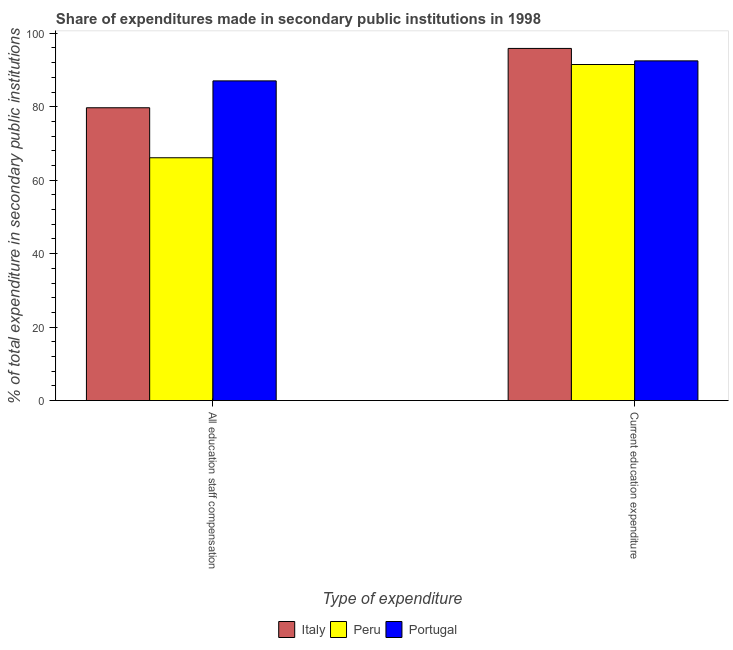How many groups of bars are there?
Offer a terse response. 2. Are the number of bars per tick equal to the number of legend labels?
Give a very brief answer. Yes. How many bars are there on the 1st tick from the right?
Ensure brevity in your answer.  3. What is the label of the 2nd group of bars from the left?
Keep it short and to the point. Current education expenditure. What is the expenditure in education in Portugal?
Ensure brevity in your answer.  92.49. Across all countries, what is the maximum expenditure in education?
Offer a terse response. 95.87. Across all countries, what is the minimum expenditure in education?
Give a very brief answer. 91.49. In which country was the expenditure in staff compensation maximum?
Your answer should be compact. Portugal. In which country was the expenditure in education minimum?
Provide a short and direct response. Peru. What is the total expenditure in staff compensation in the graph?
Give a very brief answer. 232.87. What is the difference between the expenditure in education in Peru and that in Italy?
Make the answer very short. -4.38. What is the difference between the expenditure in staff compensation in Portugal and the expenditure in education in Italy?
Your response must be concise. -8.83. What is the average expenditure in staff compensation per country?
Keep it short and to the point. 77.62. What is the difference between the expenditure in education and expenditure in staff compensation in Italy?
Keep it short and to the point. 16.15. In how many countries, is the expenditure in staff compensation greater than 72 %?
Offer a terse response. 2. What is the ratio of the expenditure in staff compensation in Portugal to that in Peru?
Keep it short and to the point. 1.32. What does the 2nd bar from the left in Current education expenditure represents?
Keep it short and to the point. Peru. How many countries are there in the graph?
Provide a succinct answer. 3. What is the difference between two consecutive major ticks on the Y-axis?
Ensure brevity in your answer.  20. Are the values on the major ticks of Y-axis written in scientific E-notation?
Give a very brief answer. No. Does the graph contain grids?
Make the answer very short. No. Where does the legend appear in the graph?
Offer a very short reply. Bottom center. How many legend labels are there?
Offer a terse response. 3. What is the title of the graph?
Offer a very short reply. Share of expenditures made in secondary public institutions in 1998. What is the label or title of the X-axis?
Make the answer very short. Type of expenditure. What is the label or title of the Y-axis?
Your response must be concise. % of total expenditure in secondary public institutions. What is the % of total expenditure in secondary public institutions of Italy in All education staff compensation?
Provide a succinct answer. 79.72. What is the % of total expenditure in secondary public institutions of Peru in All education staff compensation?
Give a very brief answer. 66.11. What is the % of total expenditure in secondary public institutions in Portugal in All education staff compensation?
Offer a terse response. 87.04. What is the % of total expenditure in secondary public institutions in Italy in Current education expenditure?
Provide a short and direct response. 95.87. What is the % of total expenditure in secondary public institutions in Peru in Current education expenditure?
Provide a succinct answer. 91.49. What is the % of total expenditure in secondary public institutions of Portugal in Current education expenditure?
Offer a very short reply. 92.49. Across all Type of expenditure, what is the maximum % of total expenditure in secondary public institutions in Italy?
Your answer should be compact. 95.87. Across all Type of expenditure, what is the maximum % of total expenditure in secondary public institutions in Peru?
Make the answer very short. 91.49. Across all Type of expenditure, what is the maximum % of total expenditure in secondary public institutions of Portugal?
Offer a terse response. 92.49. Across all Type of expenditure, what is the minimum % of total expenditure in secondary public institutions in Italy?
Ensure brevity in your answer.  79.72. Across all Type of expenditure, what is the minimum % of total expenditure in secondary public institutions in Peru?
Offer a very short reply. 66.11. Across all Type of expenditure, what is the minimum % of total expenditure in secondary public institutions of Portugal?
Your response must be concise. 87.04. What is the total % of total expenditure in secondary public institutions of Italy in the graph?
Provide a succinct answer. 175.59. What is the total % of total expenditure in secondary public institutions in Peru in the graph?
Your response must be concise. 157.6. What is the total % of total expenditure in secondary public institutions in Portugal in the graph?
Your answer should be very brief. 179.53. What is the difference between the % of total expenditure in secondary public institutions of Italy in All education staff compensation and that in Current education expenditure?
Keep it short and to the point. -16.15. What is the difference between the % of total expenditure in secondary public institutions of Peru in All education staff compensation and that in Current education expenditure?
Offer a very short reply. -25.39. What is the difference between the % of total expenditure in secondary public institutions in Portugal in All education staff compensation and that in Current education expenditure?
Offer a terse response. -5.45. What is the difference between the % of total expenditure in secondary public institutions in Italy in All education staff compensation and the % of total expenditure in secondary public institutions in Peru in Current education expenditure?
Your answer should be compact. -11.77. What is the difference between the % of total expenditure in secondary public institutions of Italy in All education staff compensation and the % of total expenditure in secondary public institutions of Portugal in Current education expenditure?
Provide a succinct answer. -12.77. What is the difference between the % of total expenditure in secondary public institutions in Peru in All education staff compensation and the % of total expenditure in secondary public institutions in Portugal in Current education expenditure?
Your answer should be very brief. -26.38. What is the average % of total expenditure in secondary public institutions of Italy per Type of expenditure?
Make the answer very short. 87.8. What is the average % of total expenditure in secondary public institutions of Peru per Type of expenditure?
Provide a short and direct response. 78.8. What is the average % of total expenditure in secondary public institutions of Portugal per Type of expenditure?
Offer a very short reply. 89.76. What is the difference between the % of total expenditure in secondary public institutions of Italy and % of total expenditure in secondary public institutions of Peru in All education staff compensation?
Make the answer very short. 13.61. What is the difference between the % of total expenditure in secondary public institutions in Italy and % of total expenditure in secondary public institutions in Portugal in All education staff compensation?
Your answer should be compact. -7.32. What is the difference between the % of total expenditure in secondary public institutions of Peru and % of total expenditure in secondary public institutions of Portugal in All education staff compensation?
Keep it short and to the point. -20.93. What is the difference between the % of total expenditure in secondary public institutions of Italy and % of total expenditure in secondary public institutions of Peru in Current education expenditure?
Provide a short and direct response. 4.38. What is the difference between the % of total expenditure in secondary public institutions of Italy and % of total expenditure in secondary public institutions of Portugal in Current education expenditure?
Make the answer very short. 3.39. What is the difference between the % of total expenditure in secondary public institutions in Peru and % of total expenditure in secondary public institutions in Portugal in Current education expenditure?
Offer a very short reply. -0.99. What is the ratio of the % of total expenditure in secondary public institutions of Italy in All education staff compensation to that in Current education expenditure?
Give a very brief answer. 0.83. What is the ratio of the % of total expenditure in secondary public institutions of Peru in All education staff compensation to that in Current education expenditure?
Provide a succinct answer. 0.72. What is the ratio of the % of total expenditure in secondary public institutions in Portugal in All education staff compensation to that in Current education expenditure?
Keep it short and to the point. 0.94. What is the difference between the highest and the second highest % of total expenditure in secondary public institutions in Italy?
Give a very brief answer. 16.15. What is the difference between the highest and the second highest % of total expenditure in secondary public institutions in Peru?
Offer a terse response. 25.39. What is the difference between the highest and the second highest % of total expenditure in secondary public institutions in Portugal?
Your answer should be compact. 5.45. What is the difference between the highest and the lowest % of total expenditure in secondary public institutions in Italy?
Offer a very short reply. 16.15. What is the difference between the highest and the lowest % of total expenditure in secondary public institutions of Peru?
Offer a terse response. 25.39. What is the difference between the highest and the lowest % of total expenditure in secondary public institutions in Portugal?
Provide a short and direct response. 5.45. 